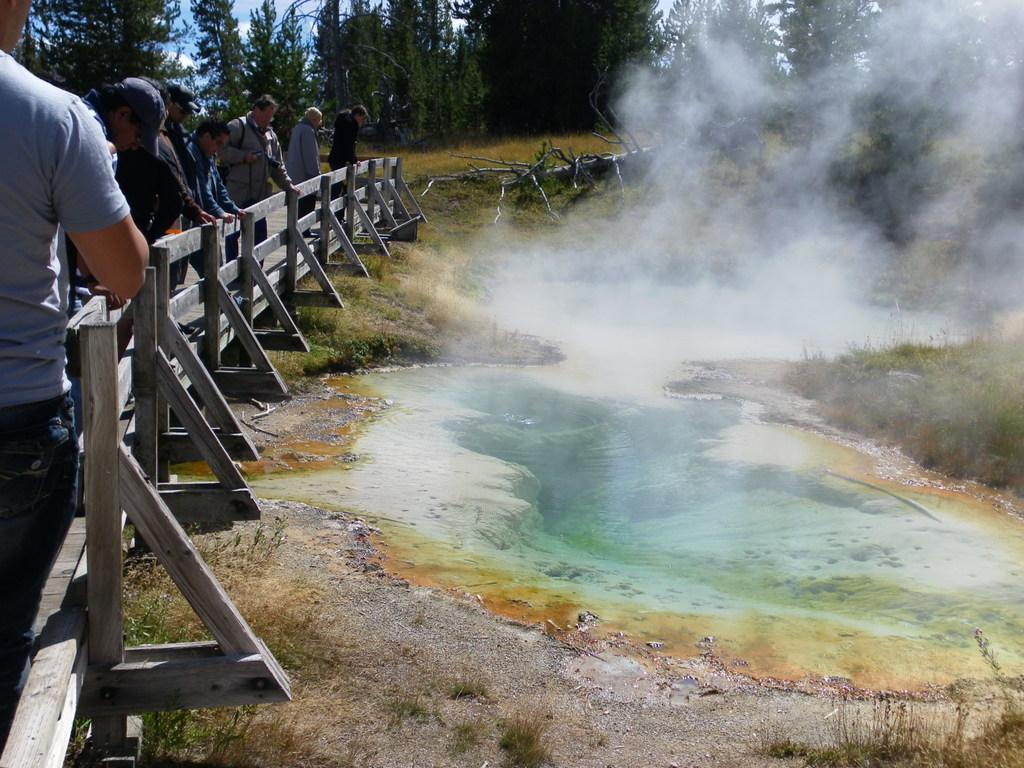Describe this image in one or two sentences. In this image there are a few people standing behind a wooden fence are looking at a hole of boiling water with smoke coming out from it, in the background of the image there are trees. 